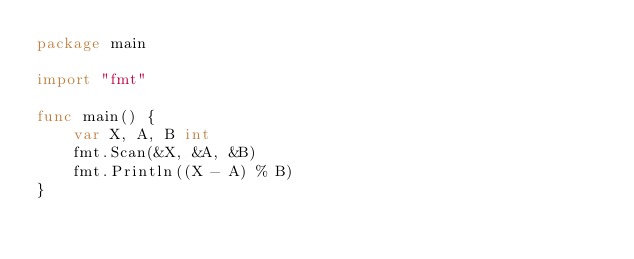<code> <loc_0><loc_0><loc_500><loc_500><_Go_>package main

import "fmt"

func main() {
	var X, A, B int
	fmt.Scan(&X, &A, &B)
	fmt.Println((X - A) % B)
}
</code> 